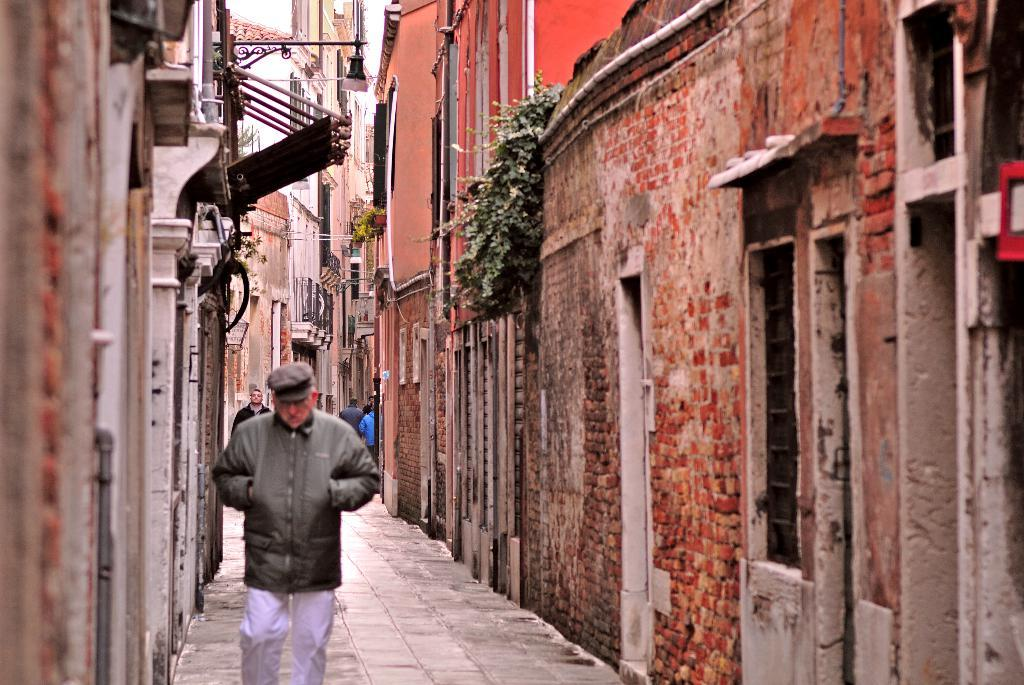How many people are in the image? There are persons in the image, but the exact number is not specified. Where are the persons located in the image? The persons are between buildings in the image. What are the persons wearing? The persons are wearing clothes in the image. What type of vegetation can be seen on the wall of a building? There are climbing plants on the wall of a building in the image. What type of list can be seen on the wall of a building in the image? There is no list present on the wall of a building in the image. What type of bun is being held by one of the persons in the image? There is no bun visible in the image, and the persons' hands are not shown. 